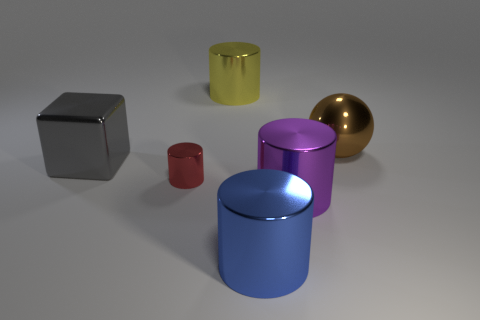There is a large cylinder that is behind the big metallic thing on the left side of the red cylinder; what is its material?
Your answer should be compact. Metal. What is the size of the cylinder to the left of the yellow shiny cylinder?
Ensure brevity in your answer.  Small. How many red things are small metal things or large spheres?
Give a very brief answer. 1. Are there any other things that are the same material as the small red cylinder?
Offer a terse response. Yes. There is a blue object that is the same shape as the red metal object; what is its material?
Your answer should be very brief. Metal. Are there the same number of red cylinders to the right of the blue thing and small red cylinders?
Provide a short and direct response. No. What size is the thing that is behind the big gray metallic thing and on the left side of the brown sphere?
Offer a very short reply. Large. Is there anything else that is the same color as the block?
Give a very brief answer. No. How big is the cube behind the cylinder that is to the left of the yellow cylinder?
Offer a terse response. Large. What color is the thing that is both behind the big metal cube and left of the large purple thing?
Offer a terse response. Yellow. 